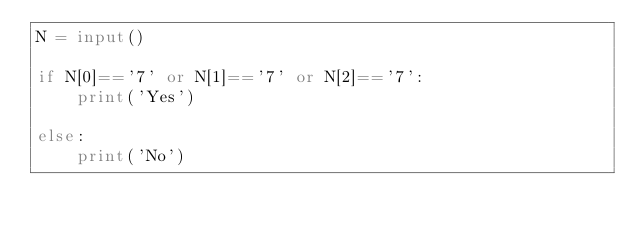Convert code to text. <code><loc_0><loc_0><loc_500><loc_500><_Python_>N = input()

if N[0]=='7' or N[1]=='7' or N[2]=='7':
    print('Yes')

else:
    print('No')
</code> 